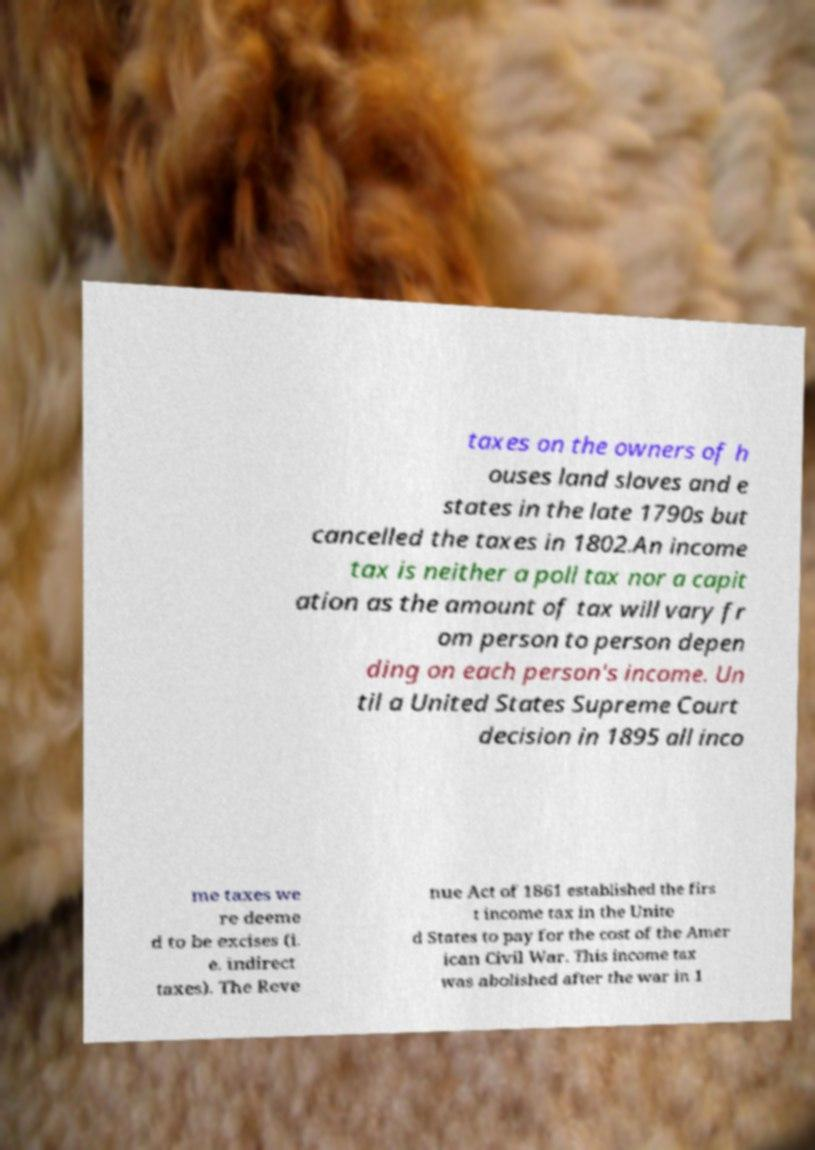Please read and relay the text visible in this image. What does it say? taxes on the owners of h ouses land slaves and e states in the late 1790s but cancelled the taxes in 1802.An income tax is neither a poll tax nor a capit ation as the amount of tax will vary fr om person to person depen ding on each person's income. Un til a United States Supreme Court decision in 1895 all inco me taxes we re deeme d to be excises (i. e. indirect taxes). The Reve nue Act of 1861 established the firs t income tax in the Unite d States to pay for the cost of the Amer ican Civil War. This income tax was abolished after the war in 1 